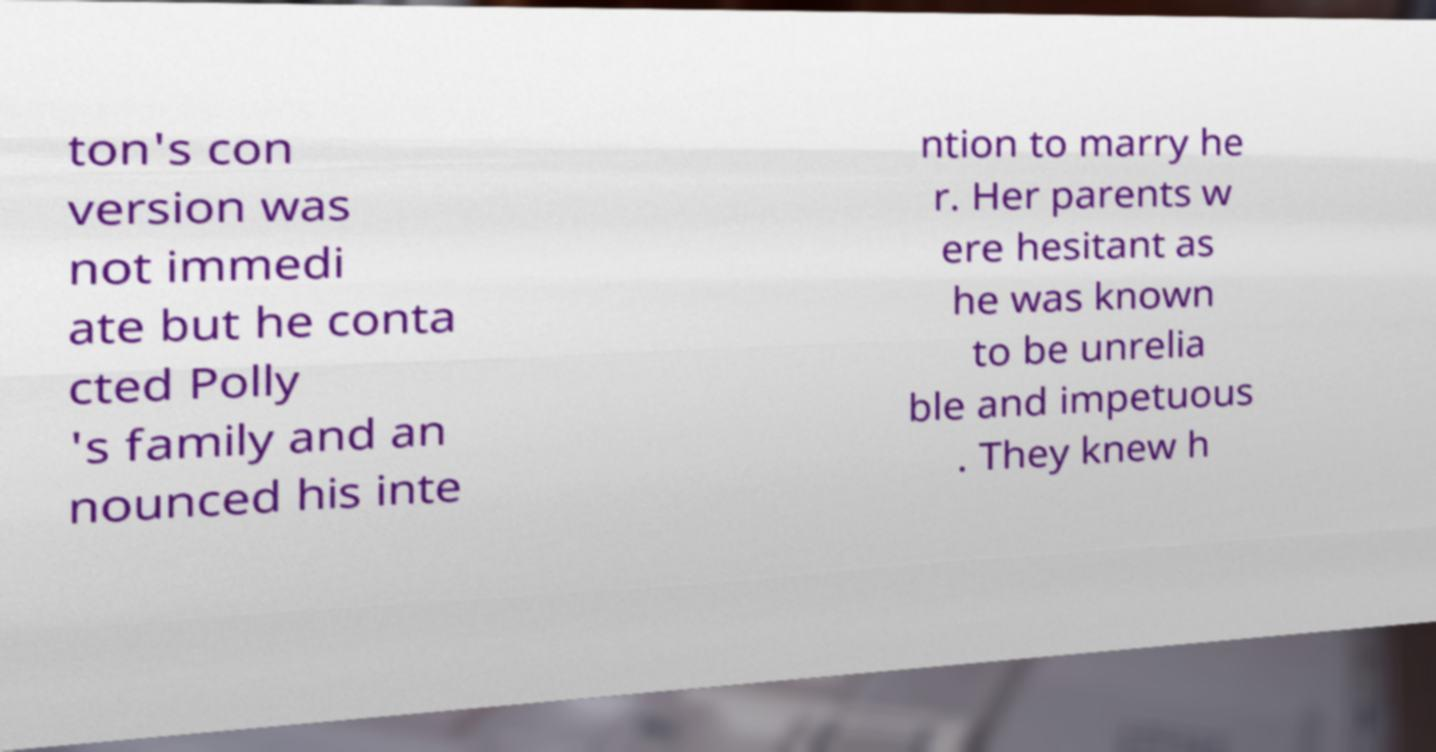There's text embedded in this image that I need extracted. Can you transcribe it verbatim? ton's con version was not immedi ate but he conta cted Polly 's family and an nounced his inte ntion to marry he r. Her parents w ere hesitant as he was known to be unrelia ble and impetuous . They knew h 